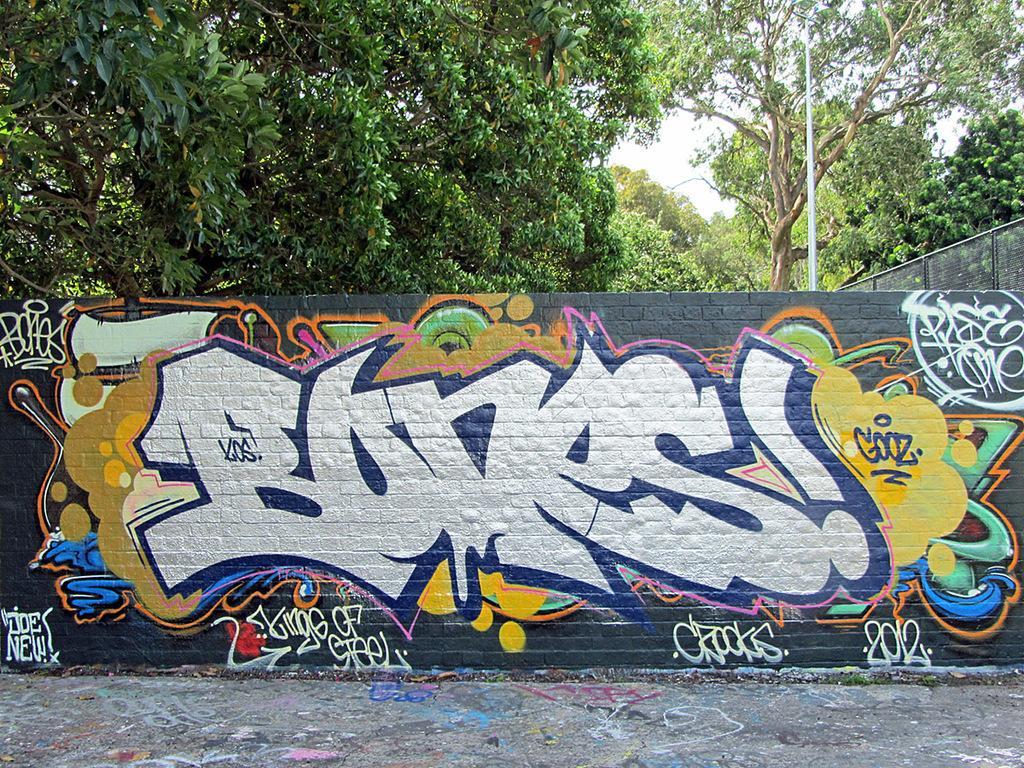Can you describe this image briefly? In the background we can see the sky, trees. On the right side of the picture we can see the fence. This picture is mainly highlighted with painting on the wall. At the bottom portion of the picture we can see the floor. 